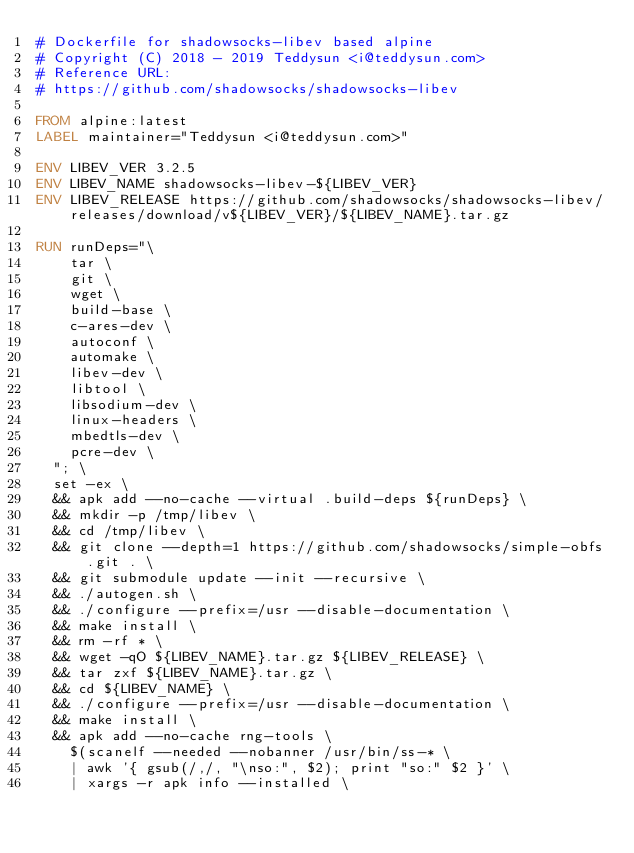Convert code to text. <code><loc_0><loc_0><loc_500><loc_500><_Dockerfile_># Dockerfile for shadowsocks-libev based alpine
# Copyright (C) 2018 - 2019 Teddysun <i@teddysun.com>
# Reference URL:
# https://github.com/shadowsocks/shadowsocks-libev

FROM alpine:latest
LABEL maintainer="Teddysun <i@teddysun.com>"

ENV LIBEV_VER 3.2.5
ENV LIBEV_NAME shadowsocks-libev-${LIBEV_VER}
ENV LIBEV_RELEASE https://github.com/shadowsocks/shadowsocks-libev/releases/download/v${LIBEV_VER}/${LIBEV_NAME}.tar.gz

RUN runDeps="\
		tar \
		git \
		wget \
		build-base \
		c-ares-dev \
		autoconf \
		automake \
		libev-dev \
		libtool \
		libsodium-dev \
		linux-headers \
		mbedtls-dev \
		pcre-dev \
	"; \
	set -ex \
	&& apk add --no-cache --virtual .build-deps ${runDeps} \
	&& mkdir -p /tmp/libev \
	&& cd /tmp/libev \
	&& git clone --depth=1 https://github.com/shadowsocks/simple-obfs.git . \
	&& git submodule update --init --recursive \
	&& ./autogen.sh \
	&& ./configure --prefix=/usr --disable-documentation \
	&& make install \
	&& rm -rf * \
	&& wget -qO ${LIBEV_NAME}.tar.gz ${LIBEV_RELEASE} \
	&& tar zxf ${LIBEV_NAME}.tar.gz \
	&& cd ${LIBEV_NAME} \
	&& ./configure --prefix=/usr --disable-documentation \
	&& make install \
	&& apk add --no-cache rng-tools \
		$(scanelf --needed --nobanner /usr/bin/ss-* \
		| awk '{ gsub(/,/, "\nso:", $2); print "so:" $2 }' \
		| xargs -r apk info --installed \</code> 